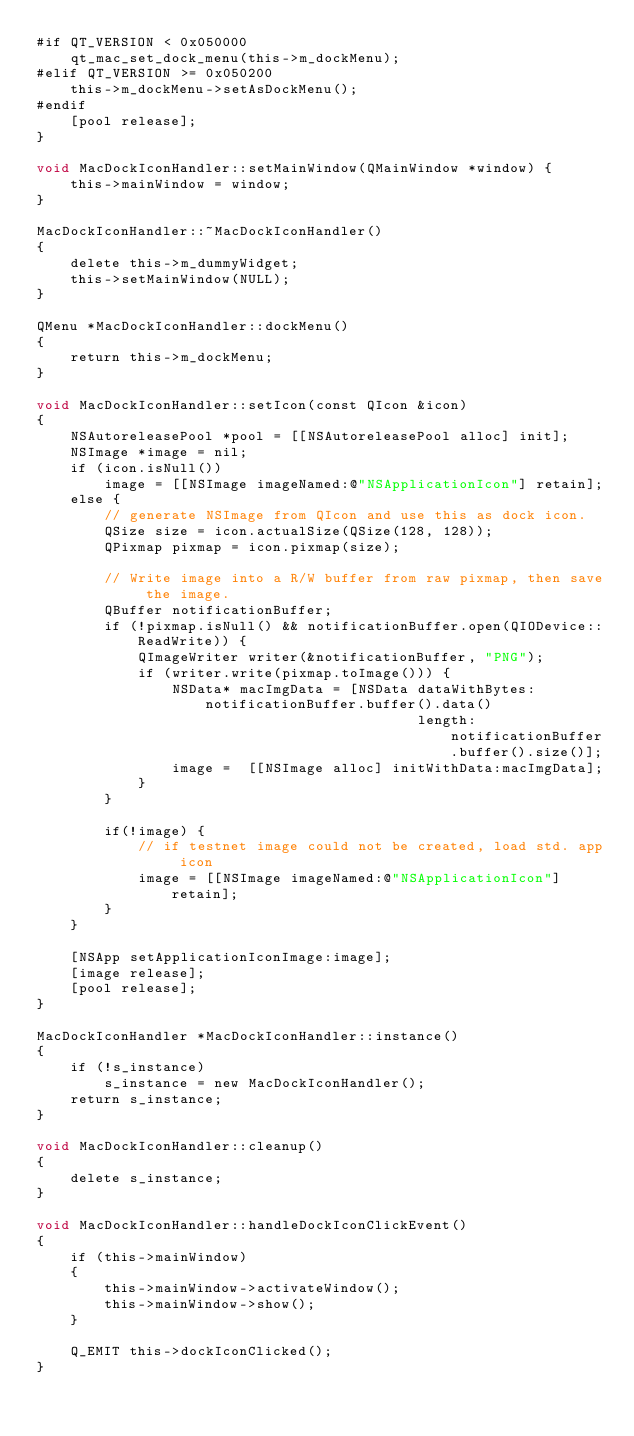<code> <loc_0><loc_0><loc_500><loc_500><_ObjectiveC_>#if QT_VERSION < 0x050000
    qt_mac_set_dock_menu(this->m_dockMenu);
#elif QT_VERSION >= 0x050200
    this->m_dockMenu->setAsDockMenu();
#endif
    [pool release];
}

void MacDockIconHandler::setMainWindow(QMainWindow *window) {
    this->mainWindow = window;
}

MacDockIconHandler::~MacDockIconHandler()
{
    delete this->m_dummyWidget;
    this->setMainWindow(NULL);
}

QMenu *MacDockIconHandler::dockMenu()
{
    return this->m_dockMenu;
}

void MacDockIconHandler::setIcon(const QIcon &icon)
{
    NSAutoreleasePool *pool = [[NSAutoreleasePool alloc] init];
    NSImage *image = nil;
    if (icon.isNull())
        image = [[NSImage imageNamed:@"NSApplicationIcon"] retain];
    else {
        // generate NSImage from QIcon and use this as dock icon.
        QSize size = icon.actualSize(QSize(128, 128));
        QPixmap pixmap = icon.pixmap(size);

        // Write image into a R/W buffer from raw pixmap, then save the image.
        QBuffer notificationBuffer;
        if (!pixmap.isNull() && notificationBuffer.open(QIODevice::ReadWrite)) {
            QImageWriter writer(&notificationBuffer, "PNG");
            if (writer.write(pixmap.toImage())) {
                NSData* macImgData = [NSData dataWithBytes:notificationBuffer.buffer().data()
                                             length:notificationBuffer.buffer().size()];
                image =  [[NSImage alloc] initWithData:macImgData];
            }
        }

        if(!image) {
            // if testnet image could not be created, load std. app icon
            image = [[NSImage imageNamed:@"NSApplicationIcon"] retain];
        }
    }

    [NSApp setApplicationIconImage:image];
    [image release];
    [pool release];
}

MacDockIconHandler *MacDockIconHandler::instance()
{
    if (!s_instance)
        s_instance = new MacDockIconHandler();
    return s_instance;
}

void MacDockIconHandler::cleanup()
{
    delete s_instance;
}

void MacDockIconHandler::handleDockIconClickEvent()
{
    if (this->mainWindow)
    {
        this->mainWindow->activateWindow();
        this->mainWindow->show();
    }

    Q_EMIT this->dockIconClicked();
}
</code> 